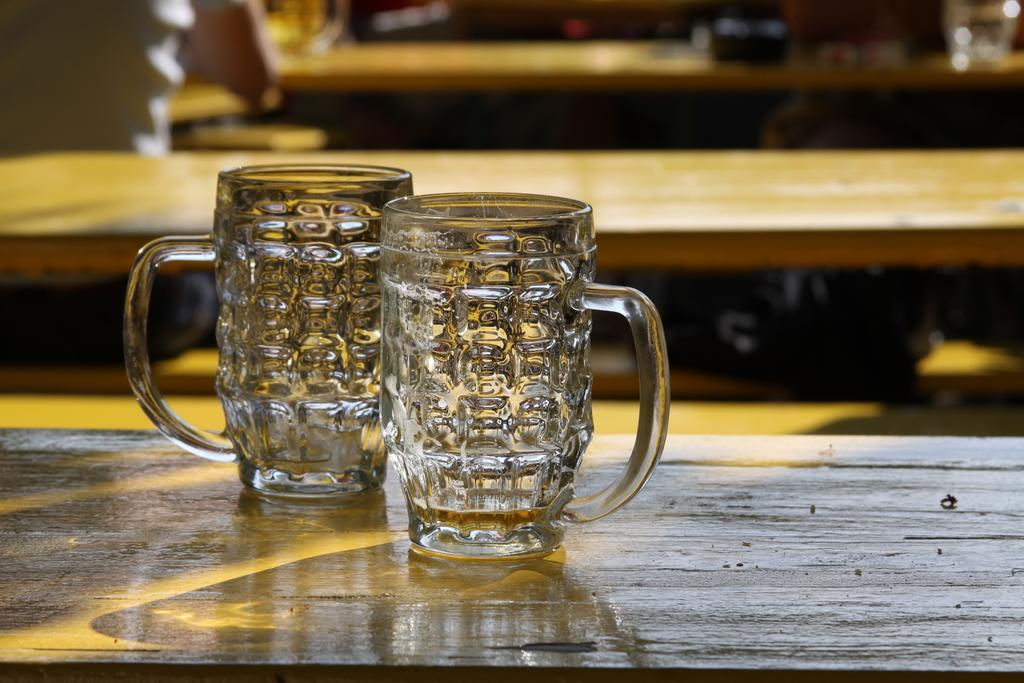What objects are on the table in the image? There are two glasses on a table in the image. What can be seen in the background of the image? There are tables and a partial view of a human sitting on a bench in the background of the image. What is the manager doing in the image? There is no manager present in the image. Can you describe the facial expression of the person sitting on the bench? There is only a partial view of the person sitting on the bench, so their face and expression cannot be determined. 